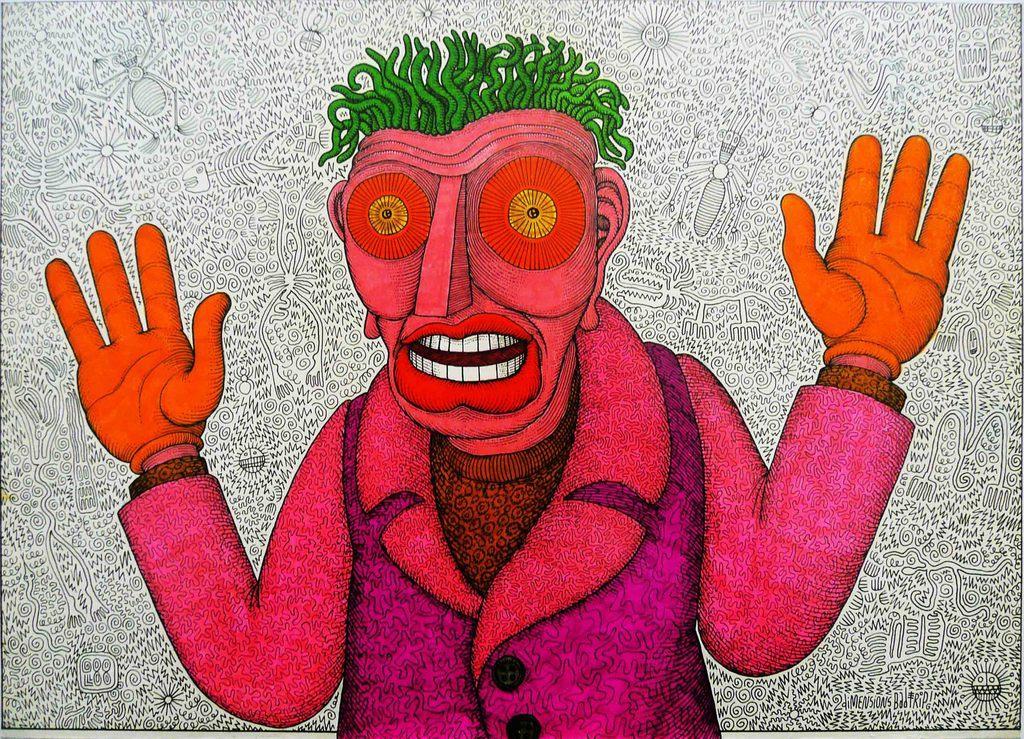In one or two sentences, can you explain what this image depicts? This is an animated image of a person and the background looks like the wall. 